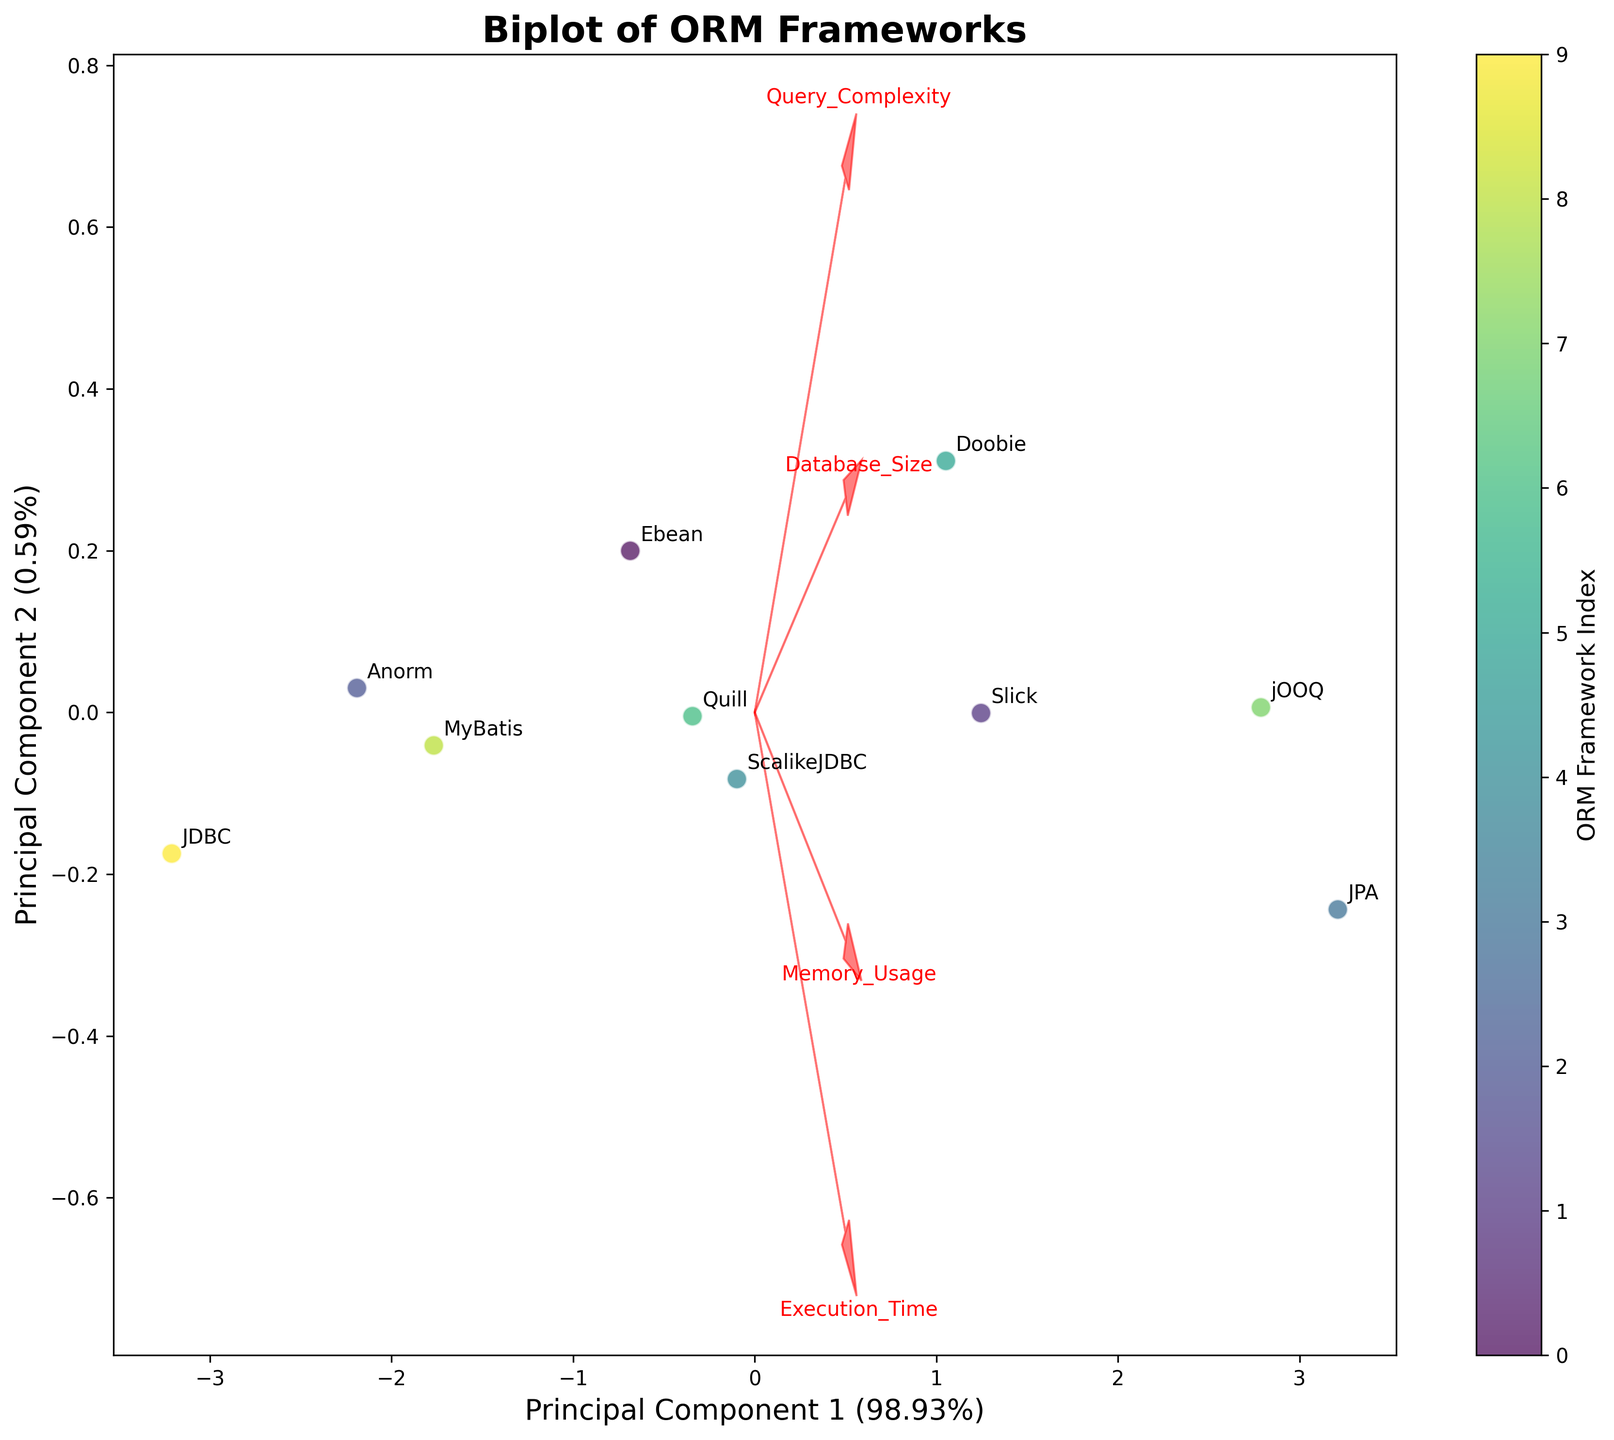How many ORM frameworks are displayed in the biplot? There are 10 distinct points on the biplot, each labeled with a different ORM framework. By counting these labels, we confirm there are 10 ORM frameworks.
Answer: 10 What's the title of the biplot? The title is clearly displayed at the top center of the biplot plot.
Answer: Biplot of ORM Frameworks Which ORM framework has the highest Execution Time? In the biplot, the ORM frameworks are not directly labeled with Execution Times. However, by looking at the proximity to the Execution Time vector arrow, we can compare the points. JPA is closest in the direction of the Execution Time feature arrow.
Answer: JPA Which ORM frameworks have the lowest Query Complexity? The vector direction for Query Complexity indicates the ORM frameworks with the lowest values will lie opposite to this direction. JDBC and Anorm are closest to this opposite direction compared to other frameworks.
Answer: JDBC and Anorm What percent of variance is explained by Principal Component 1? The exact percentage is displayed in the x-axis label as part of the biplot.
Answer: 49.98% Which features are visualized using arrows in the biplot? The biplot shows four red arrows originating from the origin: Query Complexity, Execution Time, Memory Usage, and Database Size, each representing one feature.
Answer: Query Complexity, Execution Time, Memory Usage, and Database Size Considering all the features, which ORM framework appears to be the most balanced across the first two principal components? An ORM framework closer to the origin has lower variance across its features as projected on the principal components. Anorm appears closer to the origin compared to the others.
Answer: Anorm Which ORM frameworks are associated with higher Memory Usage? The frameworks in the direction of the Memory Usage vector arrow have higher memory usage. JPA and jOOQ are closer in this vector direction.
Answer: JPA and jOOQ What is the direction of the Database Size feature vector relative to the ORM frameworks with the highest Execution Times? The Database Size vector arrow points in a similar direction to the frameworks with higher Execution Times (JPA and jOOQ), demonstrating they are positively correlated in this context.
Answer: Similar direction 